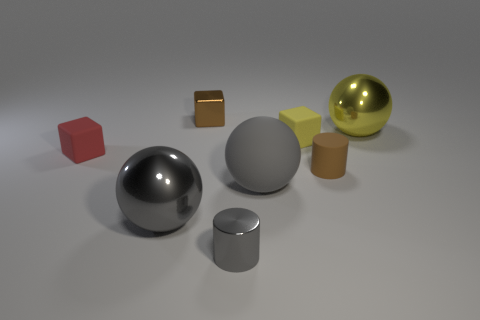Is there another matte cylinder of the same color as the rubber cylinder?
Your answer should be very brief. No. There is a gray sphere that is the same material as the large yellow object; what size is it?
Offer a terse response. Large. Is the material of the tiny brown cube the same as the tiny gray object?
Offer a very short reply. Yes. The tiny block that is behind the block that is on the right side of the tiny cylinder in front of the brown matte thing is what color?
Your response must be concise. Brown. What is the shape of the gray rubber object?
Your response must be concise. Sphere. Is the color of the tiny metallic block the same as the tiny object that is to the left of the gray metallic ball?
Ensure brevity in your answer.  No. Are there an equal number of gray things that are behind the gray matte ball and small yellow matte blocks?
Offer a terse response. No. How many shiny objects have the same size as the red cube?
Keep it short and to the point. 2. What is the shape of the large rubber thing that is the same color as the tiny metallic cylinder?
Give a very brief answer. Sphere. Are any rubber balls visible?
Make the answer very short. Yes. 